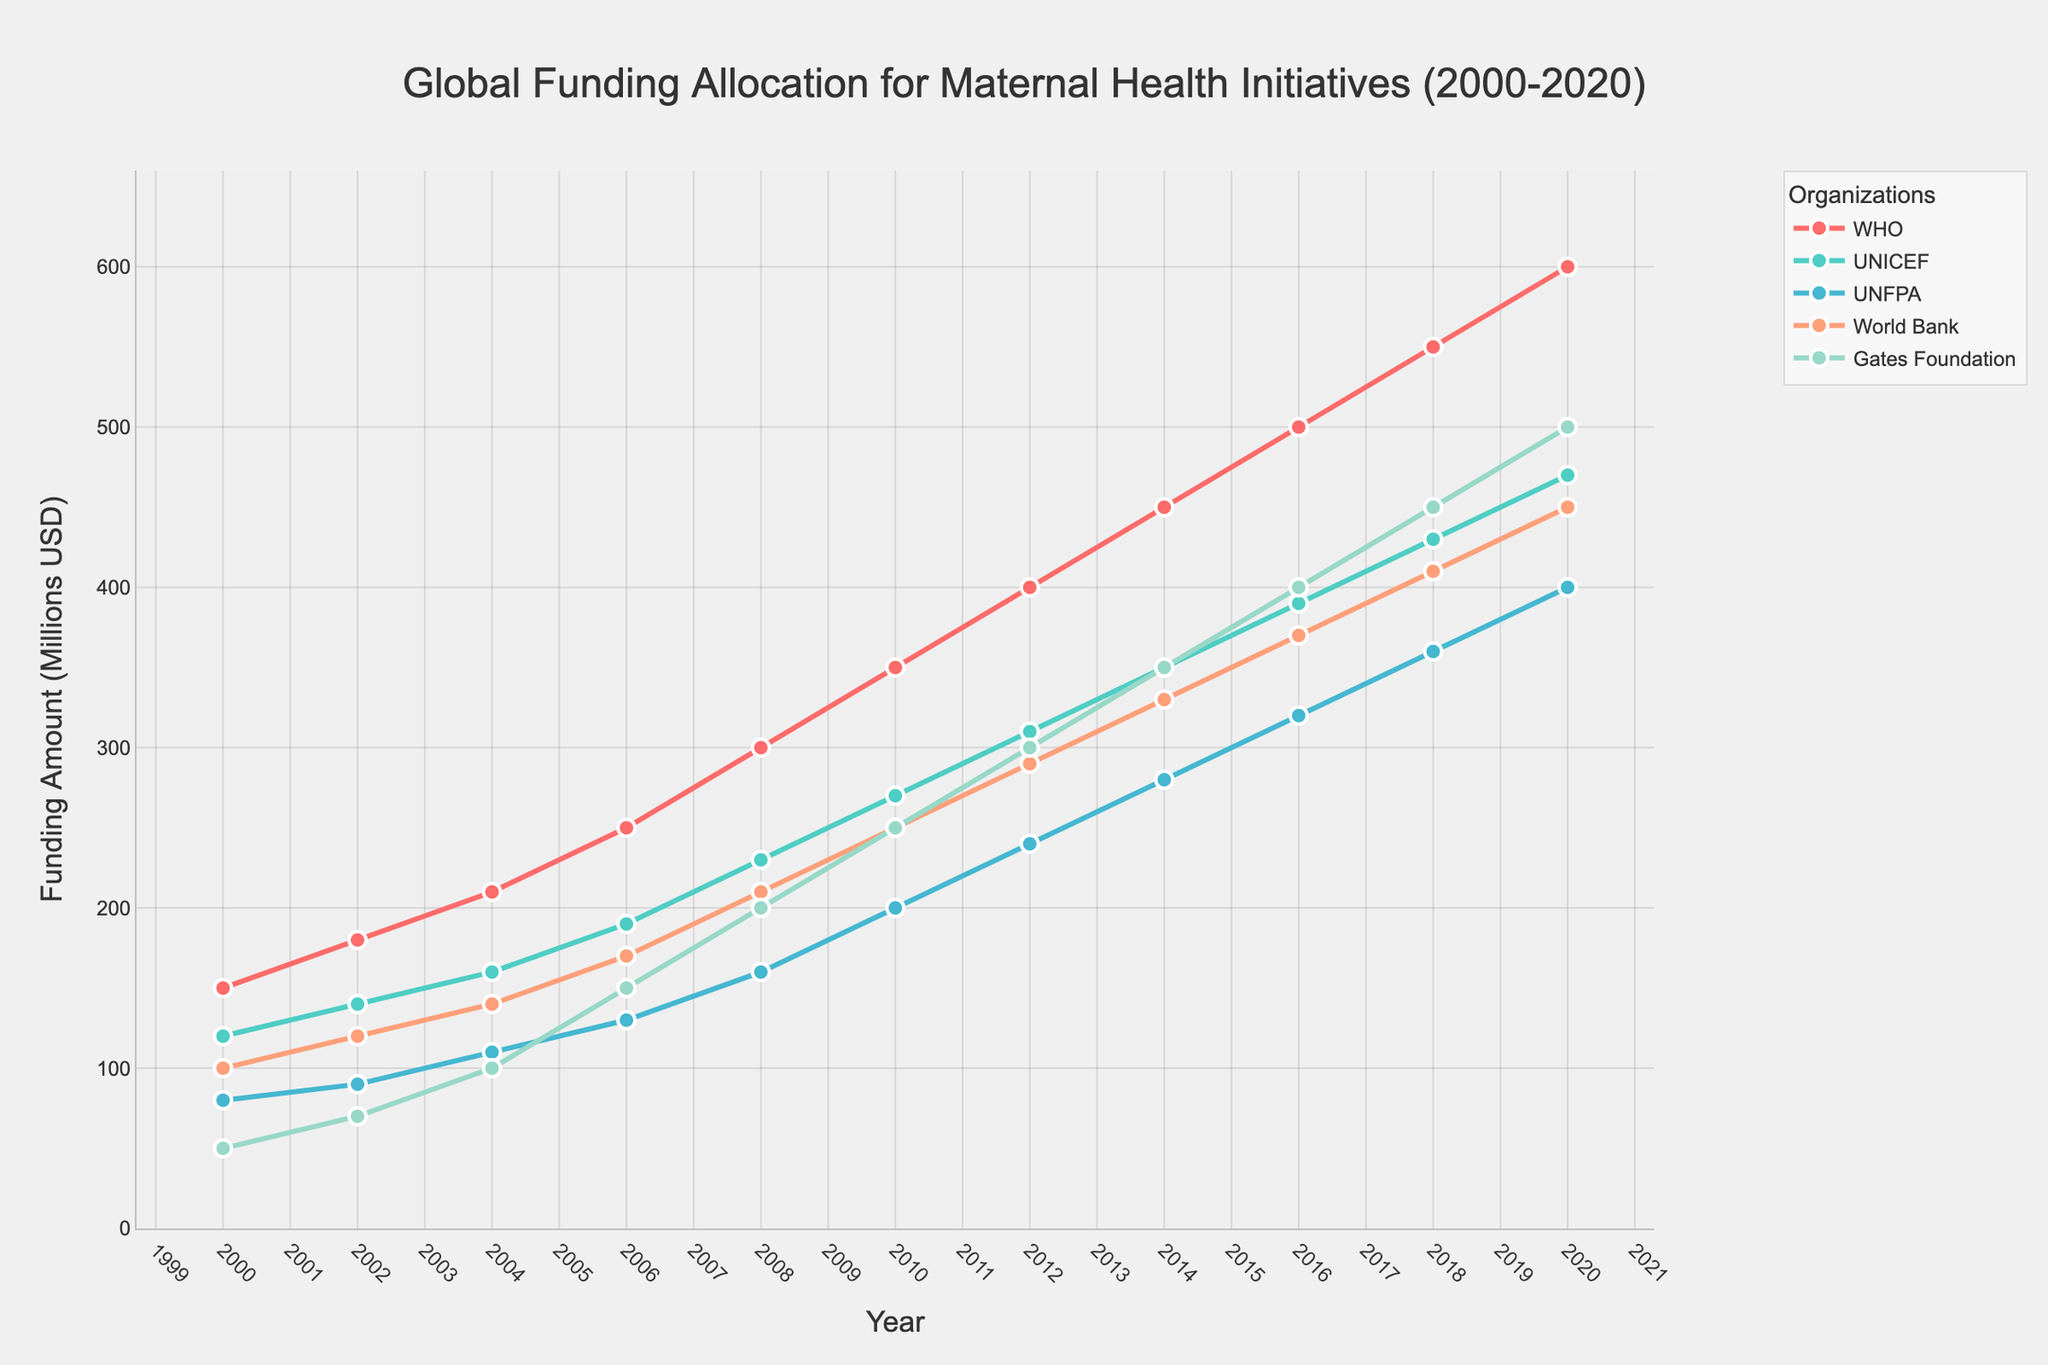Which organization allocated the highest amount of funding for maternal health initiatives in 2020? To determine the organization with the highest funding in 2020, check the endpoints of the lines on the plot. The top-most endpoint corresponds to the WHO with 600 million USD.
Answer: WHO Which organization's funding increased the most between 2000 and 2020? To find the organization with the highest increase, subtract the 2000 funding from the 2020 funding for each organization and compare the differences. WHO increased from 150 million USD to 600 million USD, which is a 450 million USD increase. None of the other organizations exhibit a larger increase.
Answer: WHO What's the average funding allocated by UNICEF from 2000 to 2020? To calculate the average, sum the yearly fundings of UNICEF and divide by the number of years. (120+140+160+190+230+270+310+350+390+430+470)/11 = 297.27 million USD
Answer: 297.27 million USD Which two organizations had the closest funding amounts in 2010? Visually inspect the 2010 funding points and compare their values. The World Bank and Gates Foundation both show very close funding levels, around 250 million USD each.
Answer: World Bank and Gates Foundation How did the funding trend for UNFPA change between the years 2000 and 2010? To understand the trend, observe the plotted line for UNFPA from 2000 to 2010. It shows a consistent upward trend, increasing from 80 million USD to 200 million USD over that period.
Answer: Consistently upward Which organization's funding shows the most variability over the two decades? To determine variability, visually assess the fluctuation and steepness of the line trends. The Gates Foundation's funding shows a more rapid and pronounced increase than the World Bank's, indicating higher variability.
Answer: Gates Foundation In which year did WHO's funding surpass 500 million USD? Locate the year on the WHO's funding line where it first exceeds 500 million USD. This occurs in 2016.
Answer: 2016 How does the funding evolution of the Gates Foundation compare to UNICEF from 2006 to 2020? Compare the slopes and endpoints of the paths for Gates Foundation and UNICEF starting from 2006 to 2020. The Gates Foundation starts from 150 million and ends at 500 million, while UNICEF starts from 190 million and ends at 470 million. Both show significant growth, but the Gates Foundation shows a steeper increase.
Answer: Gates Foundation grew faster What is the ratio of WHO's funding to UNFPA's funding in 2020? Divide WHO's funding by UNFPA's funding for 2020. WHO's funding is 600 million and UNFPA's funding is 400 million, so 600/400 = 1.5.
Answer: 1.5 